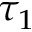<formula> <loc_0><loc_0><loc_500><loc_500>\tau _ { 1 }</formula> 